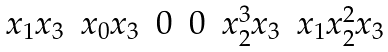<formula> <loc_0><loc_0><loc_500><loc_500>\begin{matrix} x _ { 1 } x _ { 3 } & x _ { 0 } x _ { 3 } & 0 & 0 & x _ { 2 } ^ { 3 } x _ { 3 } & x _ { 1 } x _ { 2 } ^ { 2 } x _ { 3 } \end{matrix}</formula> 